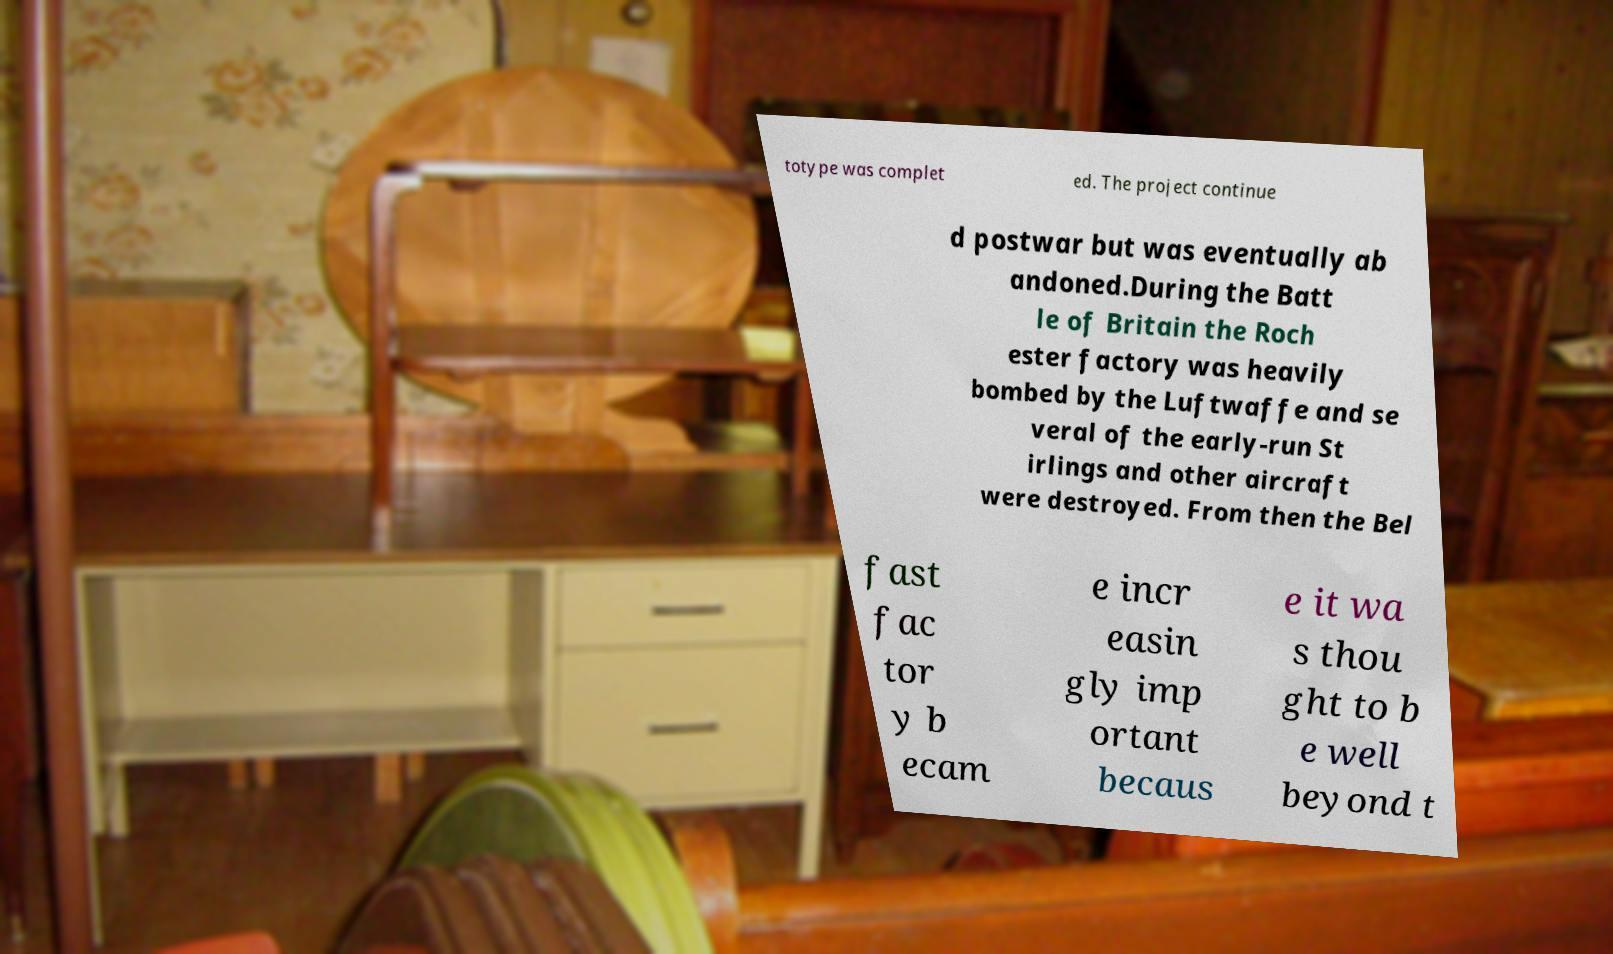What messages or text are displayed in this image? I need them in a readable, typed format. totype was complet ed. The project continue d postwar but was eventually ab andoned.During the Batt le of Britain the Roch ester factory was heavily bombed by the Luftwaffe and se veral of the early-run St irlings and other aircraft were destroyed. From then the Bel fast fac tor y b ecam e incr easin gly imp ortant becaus e it wa s thou ght to b e well beyond t 